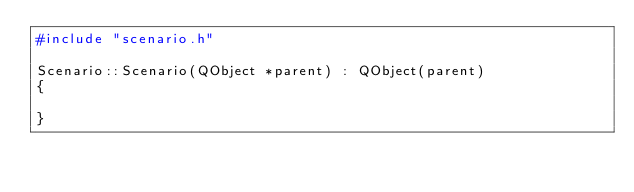Convert code to text. <code><loc_0><loc_0><loc_500><loc_500><_C++_>#include "scenario.h"

Scenario::Scenario(QObject *parent) : QObject(parent)
{

}
</code> 